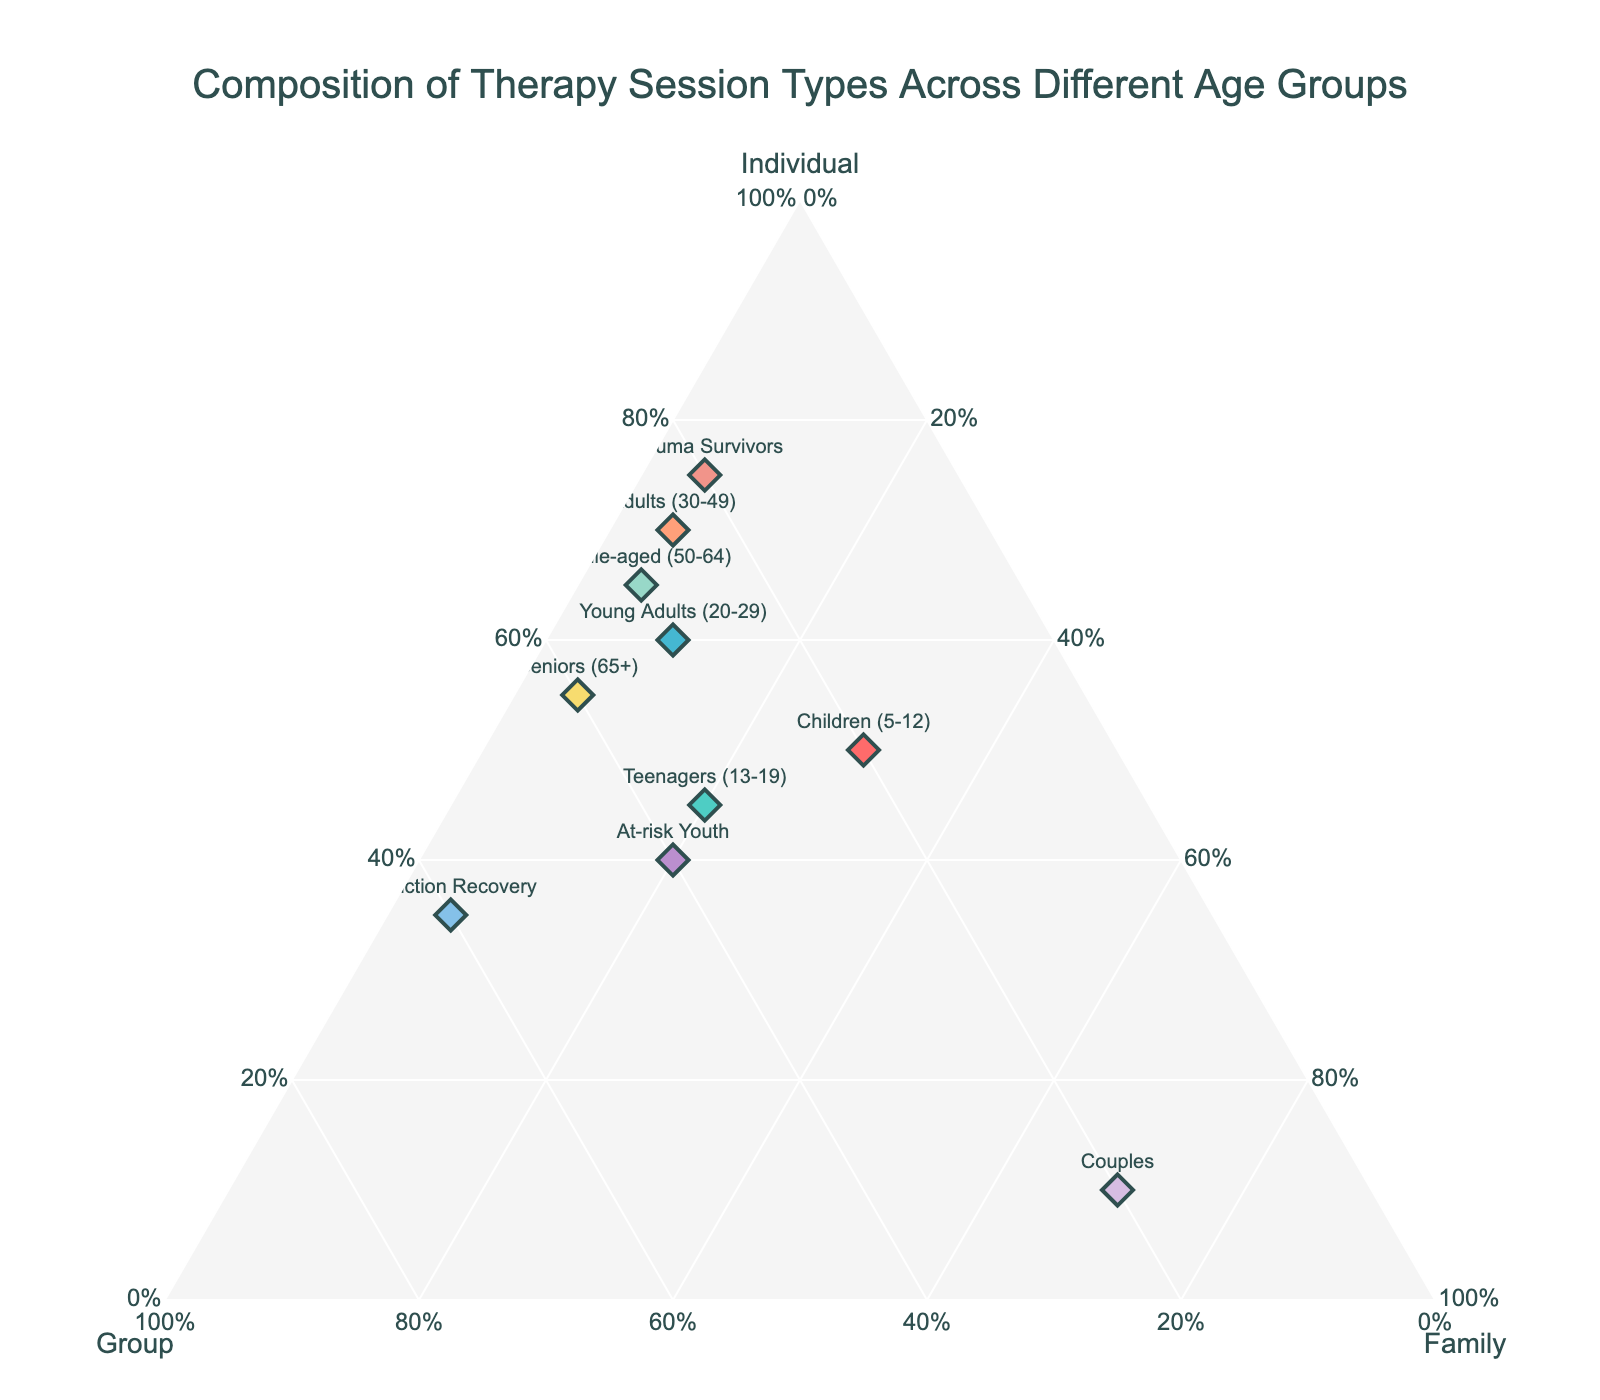What's the title of the plot? The title is often located at the top of the plot, providing a summary of what the plot represents. In this case, it reads as "Composition of Therapy Session Types Across Different Age Groups".
Answer: Composition of Therapy Session Types Across Different Age Groups How many data points are there in the plot? Each marker represents a data point corresponding to one age group. Counting all the markers on the plot gives us the total number of data points. Here, each entry in the data set represents one data point.
Answer: 10 Which age group has the highest proportion of individual therapy sessions? Locate the points positioned furthest along the "Individual" axis. The age group located closest to the "Individual" axis label has the highest proportion of individual therapy sessions.
Answer: Trauma Survivors What is the total proportion of group therapy sessions for the Children (5-12) and Teenagers (13-19) age groups combined? Sum the proportions of group therapy sessions for both age groups: Children (0.20) + Teenagers (0.35). The total is 0.20 + 0.35.
Answer: 0.55 Which age groups have the same proportion for family therapy sessions? Look for points aligned horizontally at the same level on the "Family" axis. Several groups may share the same proportion. In this plot, Children (5-12), Teenagers (13-19), At-risk Youth, and Addiction Recovery all show a proportion of 0.20 for family therapy sessions.
Answer: Children (5-12), Teenagers (13-19), At-risk Youth, and Addiction Recovery How does the composition of therapy session types differ between adults (30-49) and seniors (65+)? Compare the positions of the markers for these two age groups in terms of their distance along the "Individual", "Group", and "Family" axes. Adults (30-49) have 0.70 individual, 0.25 group, and 0.05 family, whereas Seniors (65+) have 0.55 individual, 0.40 group, and 0.05 family. The difference in proportions for individual and group therapy sessions is the main point of divergence.
Answer: Adults have a higher proportion of individual therapy, while seniors have a higher proportion of group therapy What is the combined proportion of family therapy sessions for Couples and Trauma Survivors? Sum the family therapy session proportions for both age groups: Couples (0.70) and Trauma Survivors (0.05). The total is 0.70 + 0.05.
Answer: 0.75 Which age group has the most balanced composition of therapy session types? A balanced composition implies the proportions of all three types of therapy are nearer to each other. Observing the plot shows At-risk Youth with 0.40 individual, 0.40 group, and 0.20 family therapy sessions is relatively balanced.
Answer: At-risk Youth Are there any age groups that have an identical composition of therapy types? Look for overlapping or very closely situated points. Here, no two points have identical coordinates, indicating unique compositions for each age group.
Answer: No Which age group relies the least on family therapy sessions? Identify the point situated closest to the opposite end of the "Family" axis (i.e., 0%). The points closest to the base of the "Family" axis are Adults (30-49), Middle-aged (50-64), Seniors (65+), and Trauma Survivors all with 0.05.
Answer: Adults (30-49), Middle-aged (50-64), Seniors (65+), Trauma Survivors 